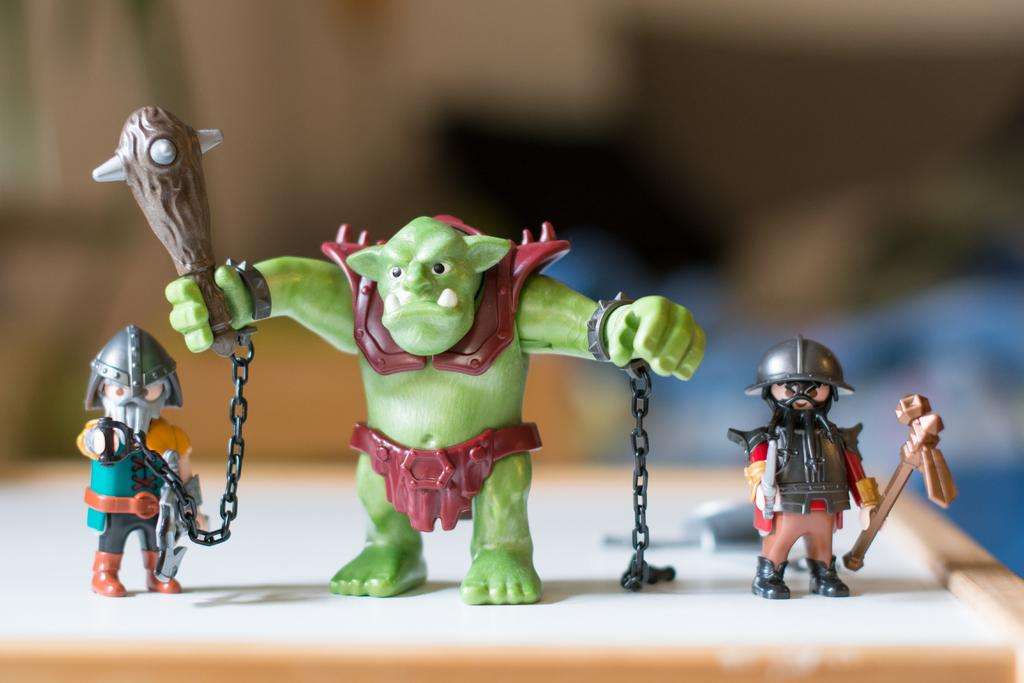What objects are on the wooden surface in the image? There are toys on a wooden surface in the image. Can you describe the background of the image? The background of the image is blurred. Is there a baby present in the image, and if so, what is the baby's suggestion for measuring the toys? There is no baby present in the image, and therefore no suggestion for measuring the toys can be provided. 